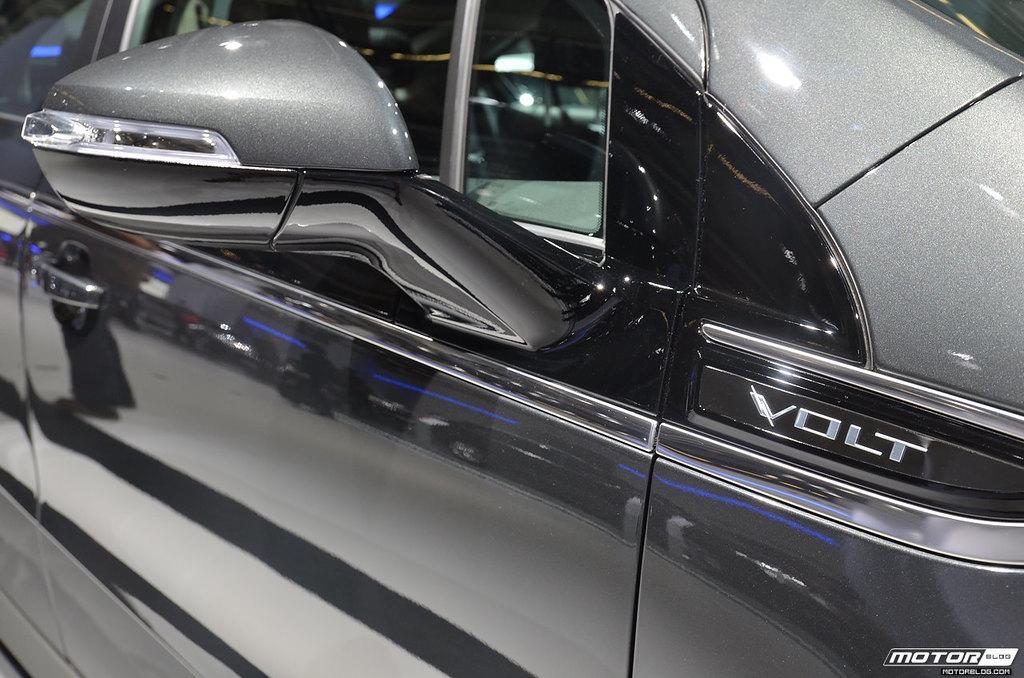Please provide a concise description of this image. In the image there is a car with door, mirror and also there is a name on the car. In the bottom right corner of the image there is something written on it. 